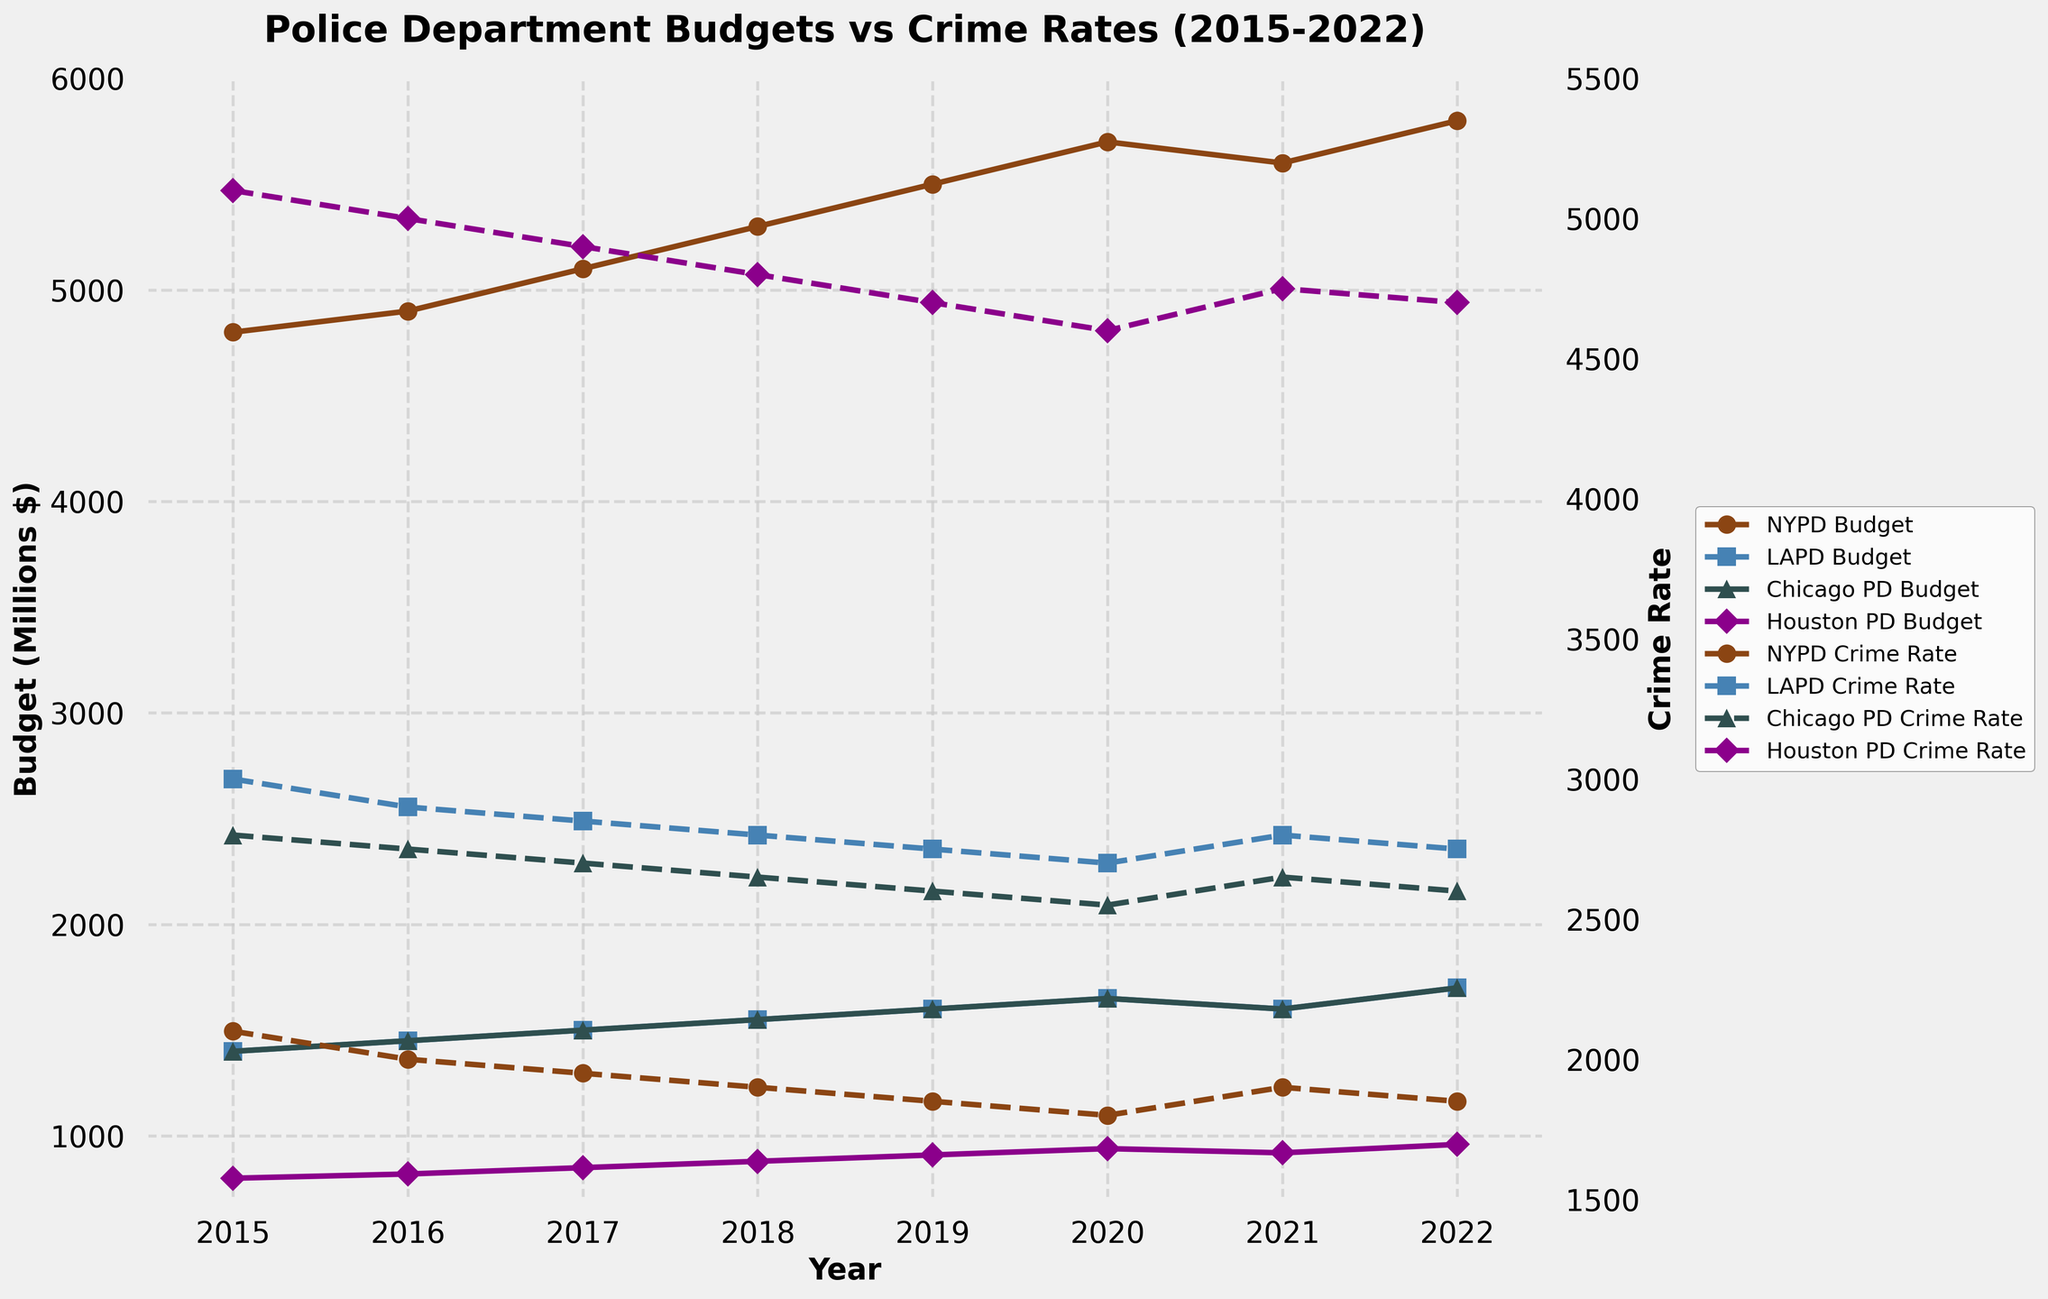Which city had the highest police budget in 2019? To find this, look at the 2019 data for all four cities' budgets. NYPD has a budget of 5500, LAPD has 1600, Chicago PD has 1600, and Houston PD has 910. The highest budget is 5500 from NYPD.
Answer: NYPD Which city had the lowest crime rate in 2020? Review the crime rates for 2020: NYPD (1800), LAPD (2700), Chicago PD (2550), and Houston PD (4600). The lowest crime rate is 1800 from NYPD.
Answer: NYPD Did LAPD's budget increase or decrease from 2020 to 2021? Look at the LAPD budget entries for 2020 (1650) and 2021 (1600). The budget decreased from 1650 to 1600.
Answer: Decrease How did the NYPD budget change from 2015 to 2022, and by how much? The budget for NYPD in 2015 is 4800 and in 2022 it is 5800. The change is 5800 - 4800 = 1000.
Answer: Increased by 1000 Which city experienced the most significant decrease in crime rate from 2015 to 2022? Calculate the crime rate difference for each city: NYPD (2100 - 1850 = 250), LAPD (3000 - 2750 = 250), Chicago PD (2800 - 2600 = 200), and Houston PD (5100 - 4700 = 400). Houston PD experienced the most significant decrease with a difference of 400.
Answer: Houston PD Which city's budget stayed constant from 2021 to 2022? Compare the budgets for each city in 2021 and 2022. NYPD (5600, 5800), LAPD (1600, 1700), Chicago PD (2650, 2600), Houston PD (920, 960). No city's budget stayed constant.
Answer: None What was the crime rate for Chicago PD in 2018 compared to its budget for the same year? Identify the crime rate (2650) and budget (1550) for Chicago PD in 2018. Chicago PD's crime rate was higher than its budget.
Answer: Crime rate was higher What is the overall trend in the NYPD's crime rate from 2015 to 2022? Look at the NYPD crime rate trend over the years: 2100, 2000, 1950, 1900, 1850, 1800, 1900, 1850. The overall trend is a decrease.
Answer: Decreasing How much did Houston PD's crime rate decrease from 2015 to 2022? Calculate the difference: 5100 (2015) - 4700 (2022) = 400.
Answer: Decreased by 400 Which police department had a higher budget in 2017, LAPD or Chicago PD? Compare the budgets for LAPD (1500) and Chicago PD (1500) in 2017. Both departments had the same budget.
Answer: Equal 